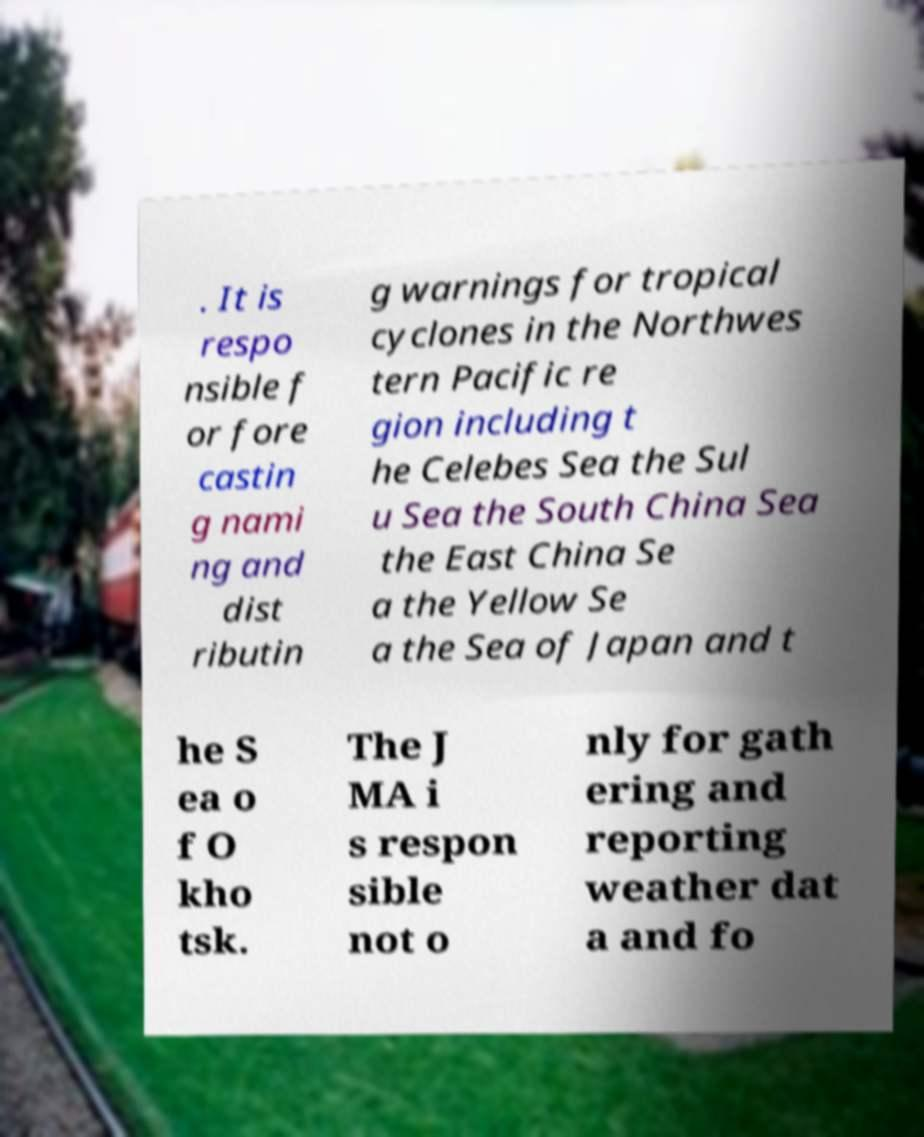For documentation purposes, I need the text within this image transcribed. Could you provide that? . It is respo nsible f or fore castin g nami ng and dist ributin g warnings for tropical cyclones in the Northwes tern Pacific re gion including t he Celebes Sea the Sul u Sea the South China Sea the East China Se a the Yellow Se a the Sea of Japan and t he S ea o f O kho tsk. The J MA i s respon sible not o nly for gath ering and reporting weather dat a and fo 